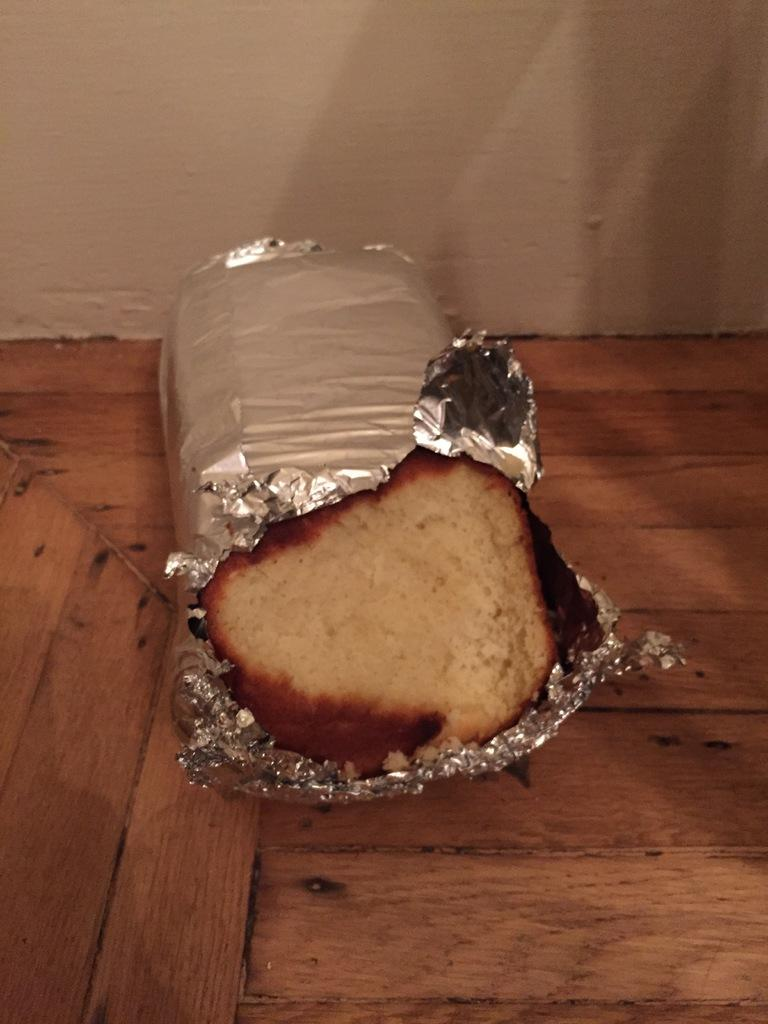What is the main subject of the image? There is a food item on a wooden platform. Can you describe the surface on which the food item is placed? The food item is placed on a wooden platform. What can be seen in the background of the image? There is a wall in the background of the image. How many mint leaves are visible on the food item in the image? There is no mention of mint leaves in the image, so it is not possible to determine their presence or quantity. 